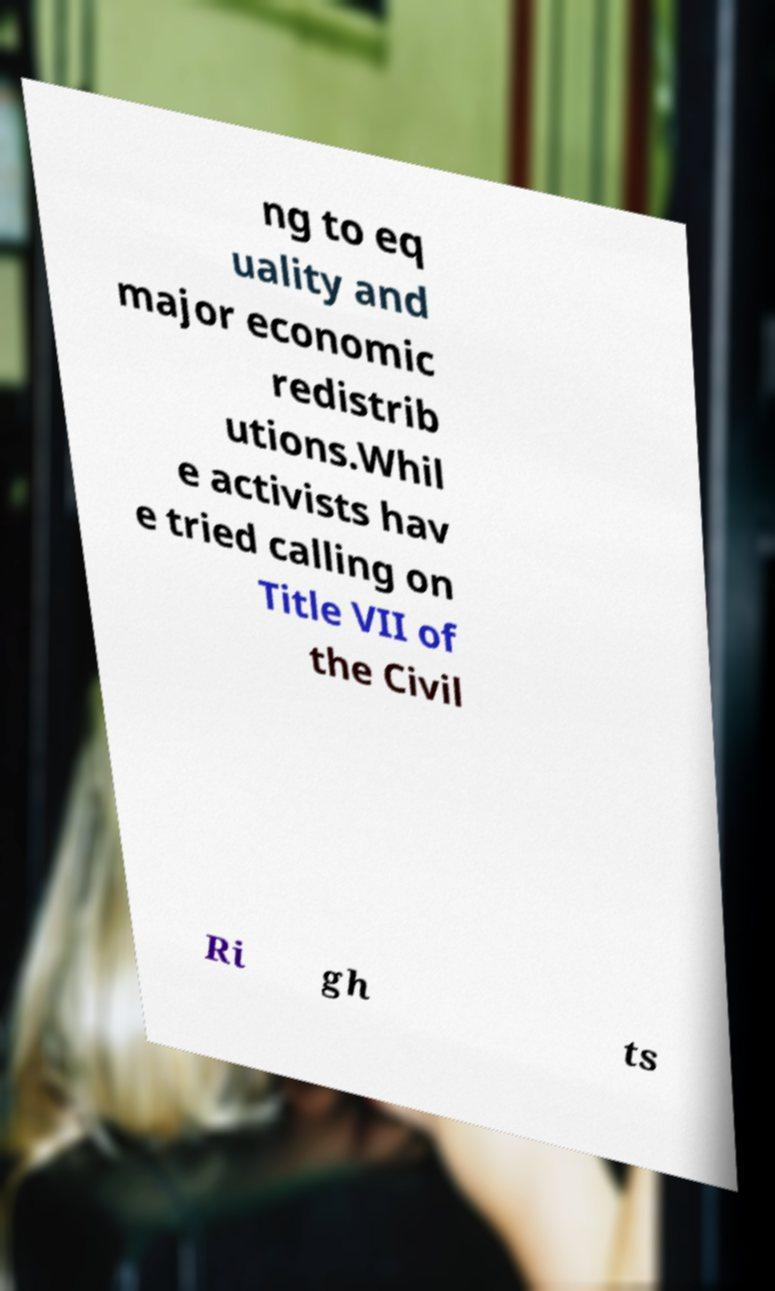Can you accurately transcribe the text from the provided image for me? ng to eq uality and major economic redistrib utions.Whil e activists hav e tried calling on Title VII of the Civil Ri gh ts 